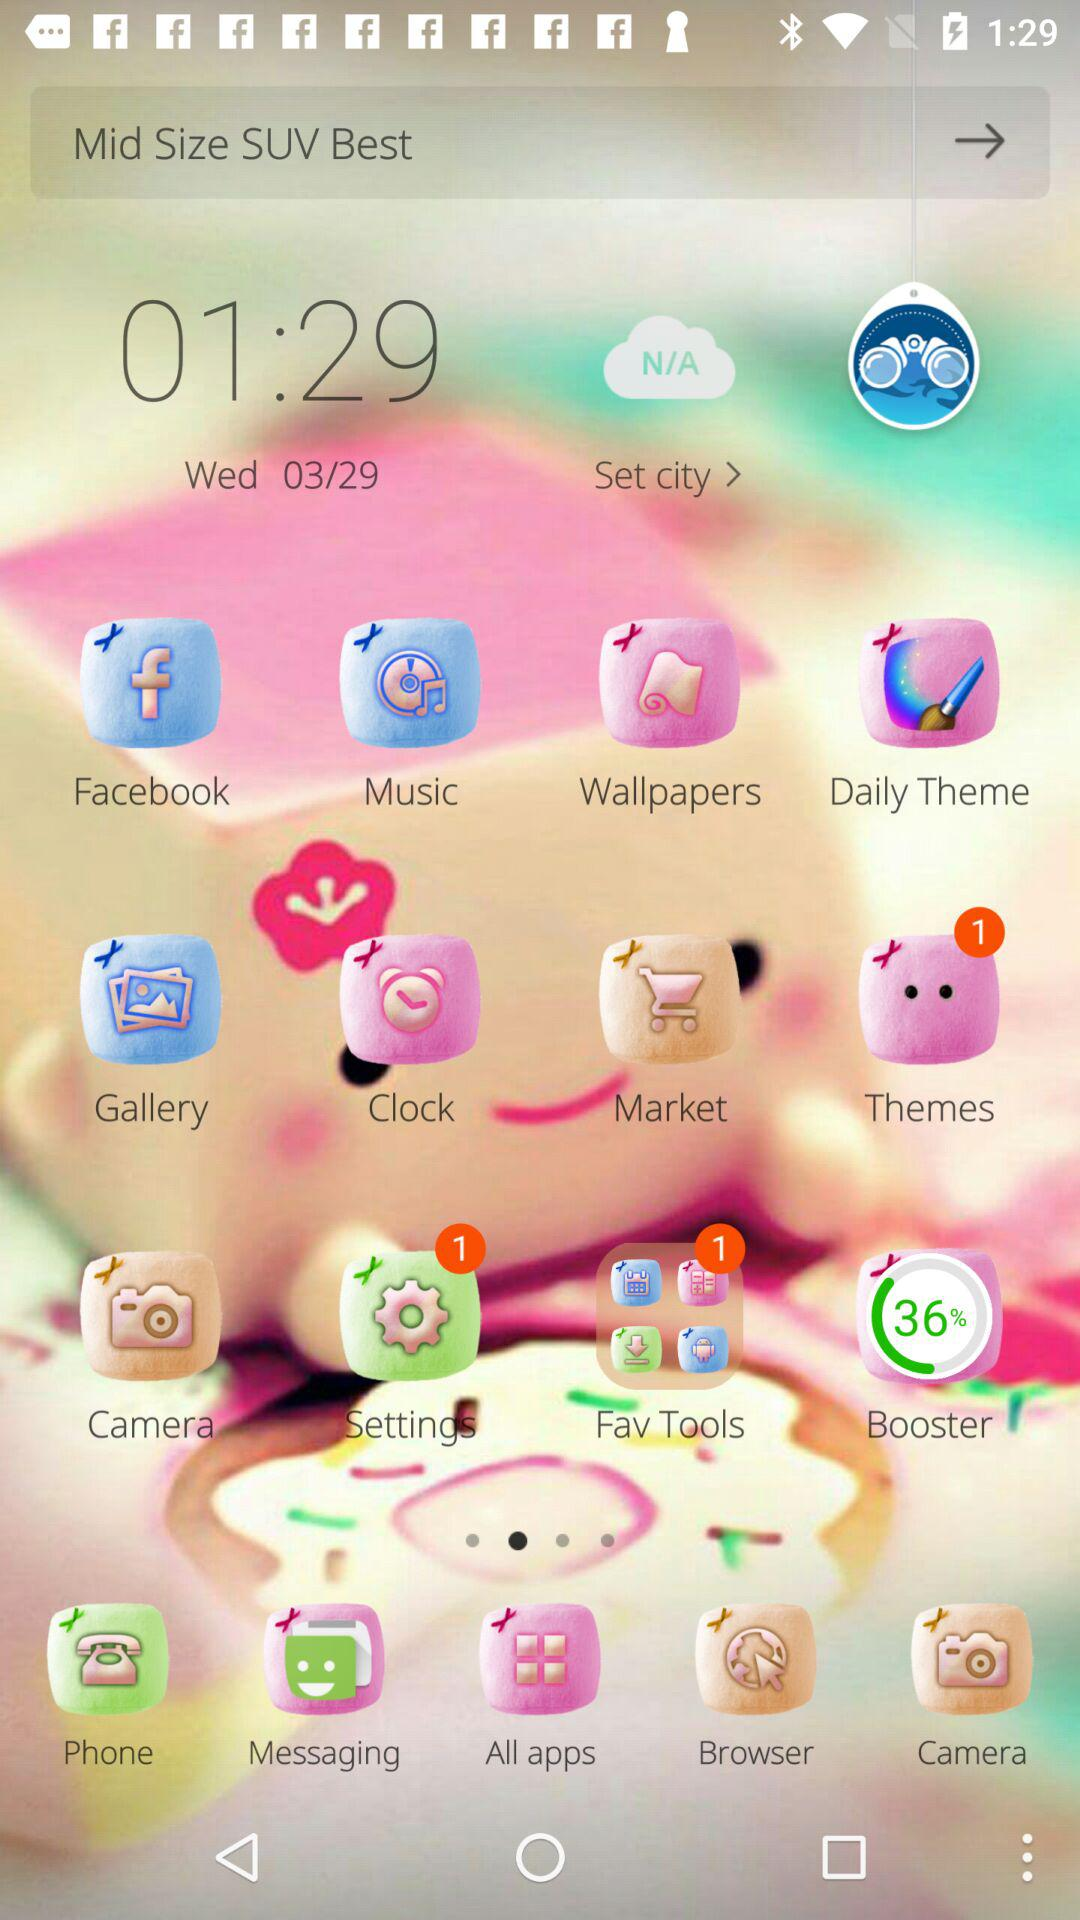What is the mentioned time? The mentioned time is 01:29. 